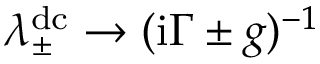Convert formula to latex. <formula><loc_0><loc_0><loc_500><loc_500>\lambda _ { \pm } ^ { d c } \rightarrow ( i \Gamma \pm g ) ^ { - 1 }</formula> 